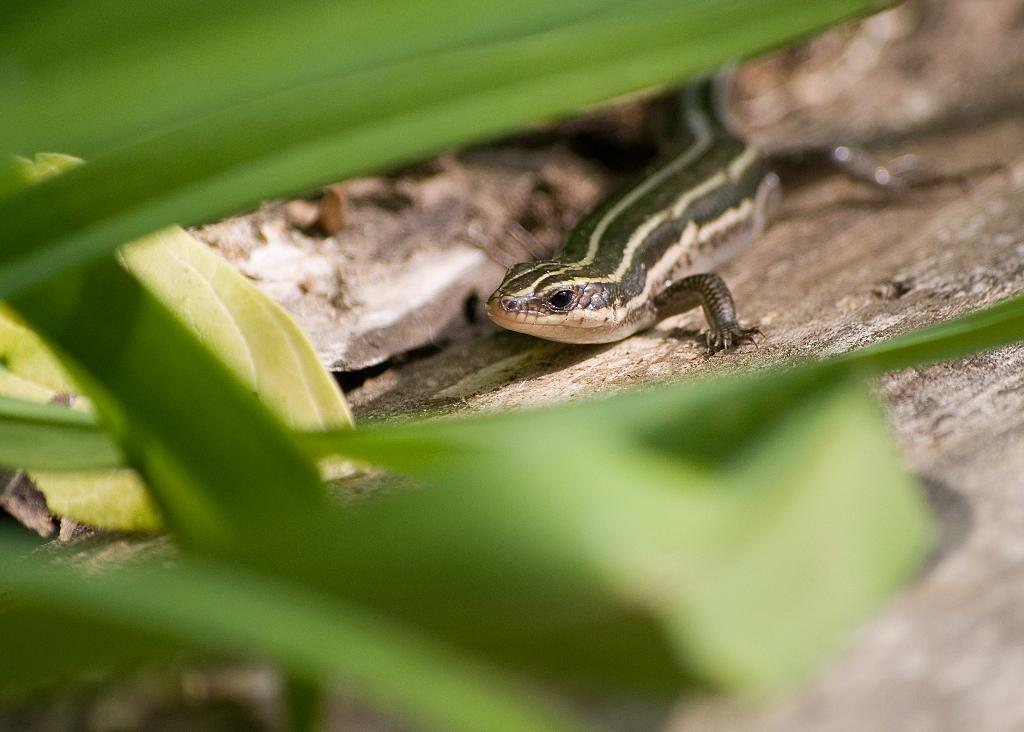What type of animal is in the picture? There is a lizard in the picture. What can be seen in the background of the picture? There are green color leaves in the picture. What type of popcorn is being served in the basket in the image? There is no basket or popcorn present in the image; it only features a lizard and green leaves. 